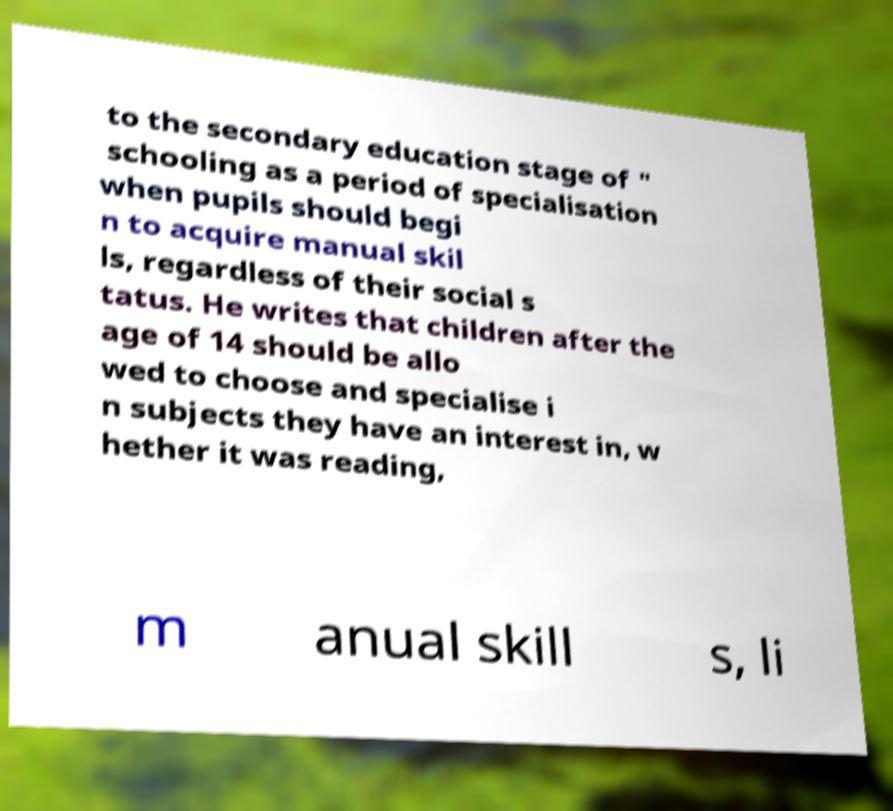What messages or text are displayed in this image? I need them in a readable, typed format. to the secondary education stage of " schooling as a period of specialisation when pupils should begi n to acquire manual skil ls, regardless of their social s tatus. He writes that children after the age of 14 should be allo wed to choose and specialise i n subjects they have an interest in, w hether it was reading, m anual skill s, li 